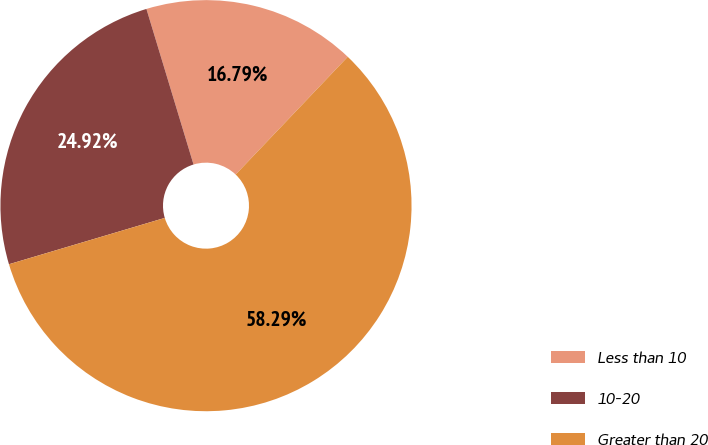<chart> <loc_0><loc_0><loc_500><loc_500><pie_chart><fcel>Less than 10<fcel>10-20<fcel>Greater than 20<nl><fcel>16.79%<fcel>24.92%<fcel>58.29%<nl></chart> 